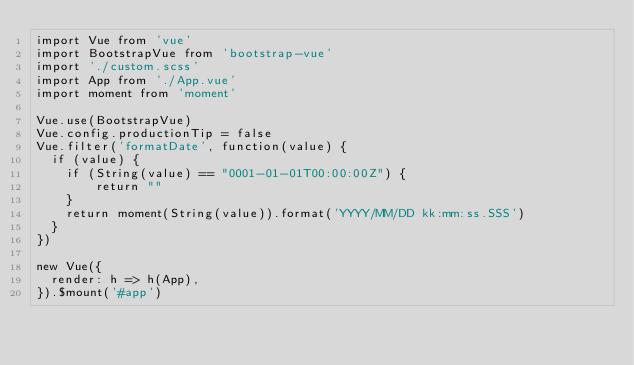Convert code to text. <code><loc_0><loc_0><loc_500><loc_500><_JavaScript_>import Vue from 'vue'
import BootstrapVue from 'bootstrap-vue'
import './custom.scss'
import App from './App.vue'
import moment from 'moment'

Vue.use(BootstrapVue)
Vue.config.productionTip = false
Vue.filter('formatDate', function(value) {
  if (value) {
    if (String(value) == "0001-01-01T00:00:00Z") {
        return ""
    }
    return moment(String(value)).format('YYYY/MM/DD kk:mm:ss.SSS')
  }
})

new Vue({
  render: h => h(App),
}).$mount('#app')
</code> 